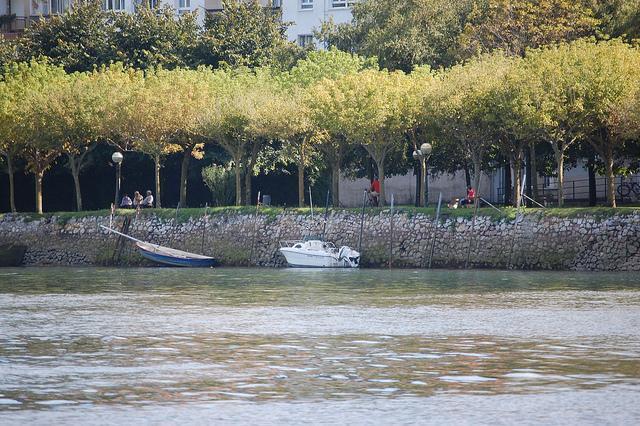How many buses are there?
Give a very brief answer. 0. 